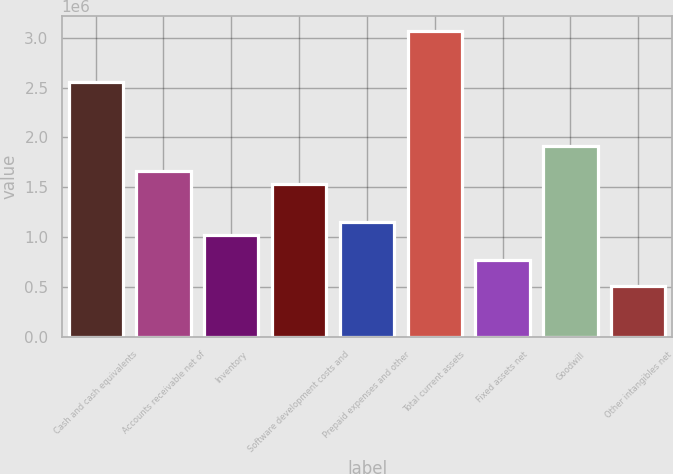Convert chart to OTSL. <chart><loc_0><loc_0><loc_500><loc_500><bar_chart><fcel>Cash and cash equivalents<fcel>Accounts receivable net of<fcel>Inventory<fcel>Software development costs and<fcel>Prepaid expenses and other<fcel>Total current assets<fcel>Fixed assets net<fcel>Goodwill<fcel>Other intangibles net<nl><fcel>2.55512e+06<fcel>1.66102e+06<fcel>1.02238e+06<fcel>1.5333e+06<fcel>1.15011e+06<fcel>3.06604e+06<fcel>766926<fcel>1.91648e+06<fcel>511469<nl></chart> 